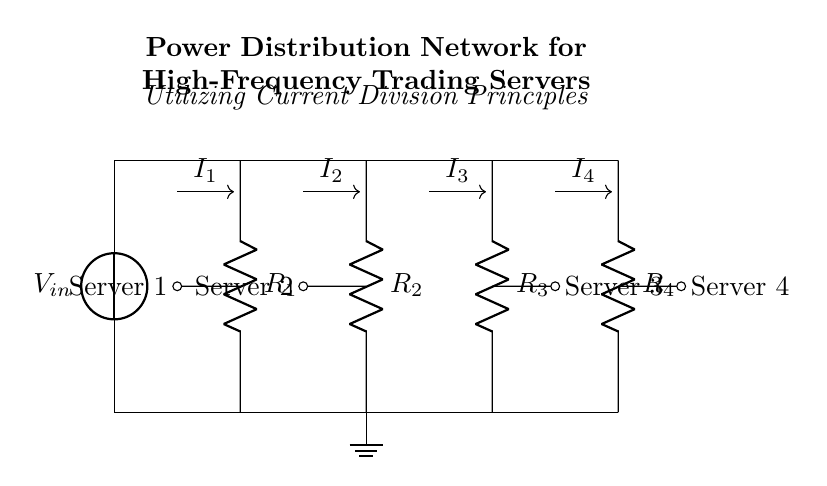What is the total number of resistors in the circuit? There are four resistors labeled R1, R2, R3, and R4 connected in parallel in the current divider network.
Answer: Four What type of circuit is implemented here? This is a current divider circuit, where the total current is divided among the parallel resistors connected to a voltage source.
Answer: Current divider Which component is the power source? The power source is represented by the voltage source labeled Vin at the top of the circuit diagram.
Answer: Vin What is the role of the resistors R1 and R2? Resistors R1 and R2 are part of the current divider that divides the input current into two branches to supply power to the respective servers connected to them.
Answer: Current division How many servers are connected to the circuit? There are four servers connected, each corresponding to a resistor in the current divider.
Answer: Four If the resistance of R3 is reduced, what effect does that have on the currents through R1, R2, and R4? Reducing the resistance of R3 will increase the overall current through the circuit and subsequently increase the current through R1, R2, and R4 due to the principles of current division.
Answer: Increase What is the expected behavior of the current distribution among the resistors? The current will be inversely proportional to the resistance values; the lower the resistance, the greater the current through that branch.
Answer: Inverse relationship 